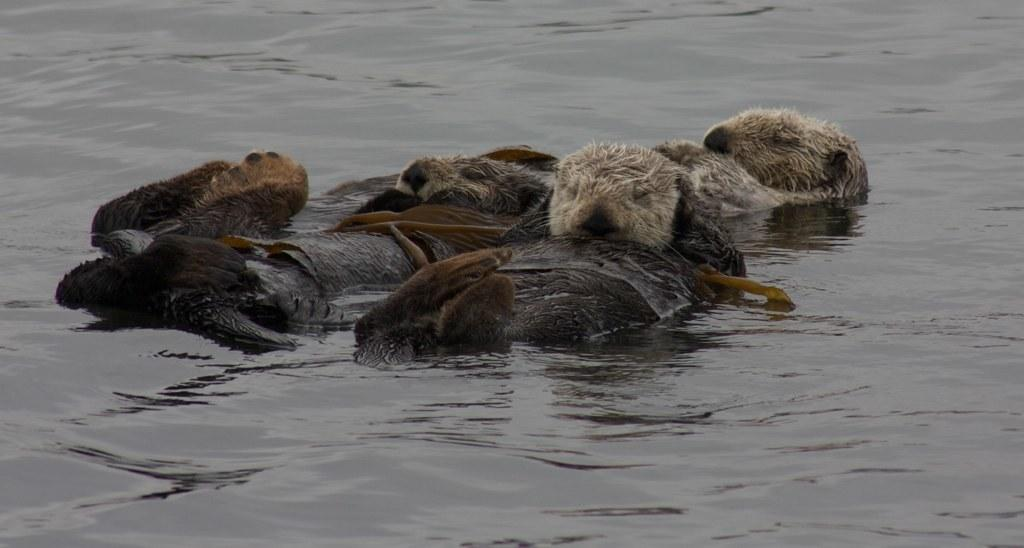What type of animals can be seen in the image? There are animals in the water in the image. Can you describe the setting where the animals are located? The animals are located in the water. What might the animals be doing in the water? The animals might be swimming or interacting with each other in the water. What type of hat is the rock wearing in the image? There is no rock or hat present in the image. 